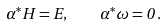Convert formula to latex. <formula><loc_0><loc_0><loc_500><loc_500>\alpha ^ { * } H = E , \quad \alpha ^ { * } \omega = 0 \, .</formula> 